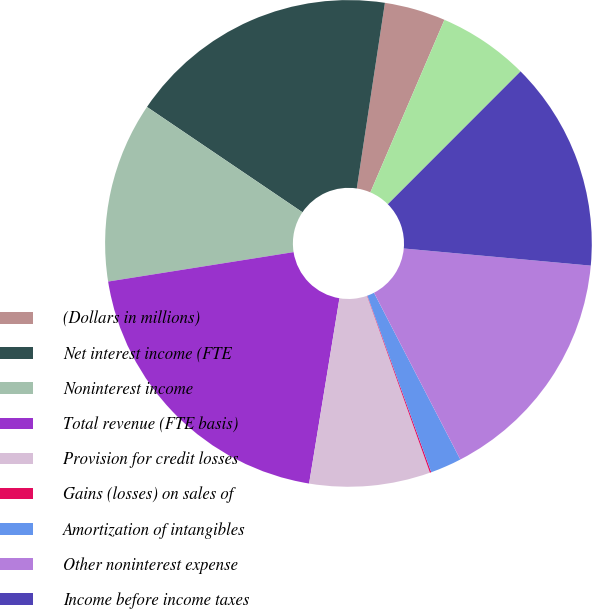Convert chart to OTSL. <chart><loc_0><loc_0><loc_500><loc_500><pie_chart><fcel>(Dollars in millions)<fcel>Net interest income (FTE<fcel>Noninterest income<fcel>Total revenue (FTE basis)<fcel>Provision for credit losses<fcel>Gains (losses) on sales of<fcel>Amortization of intangibles<fcel>Other noninterest expense<fcel>Income before income taxes<fcel>Income tax expense<nl><fcel>4.06%<fcel>17.92%<fcel>11.98%<fcel>19.91%<fcel>8.02%<fcel>0.09%<fcel>2.08%<fcel>15.94%<fcel>13.96%<fcel>6.04%<nl></chart> 